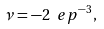<formula> <loc_0><loc_0><loc_500><loc_500>\nu = - 2 \ e p ^ { - 3 } ,</formula> 